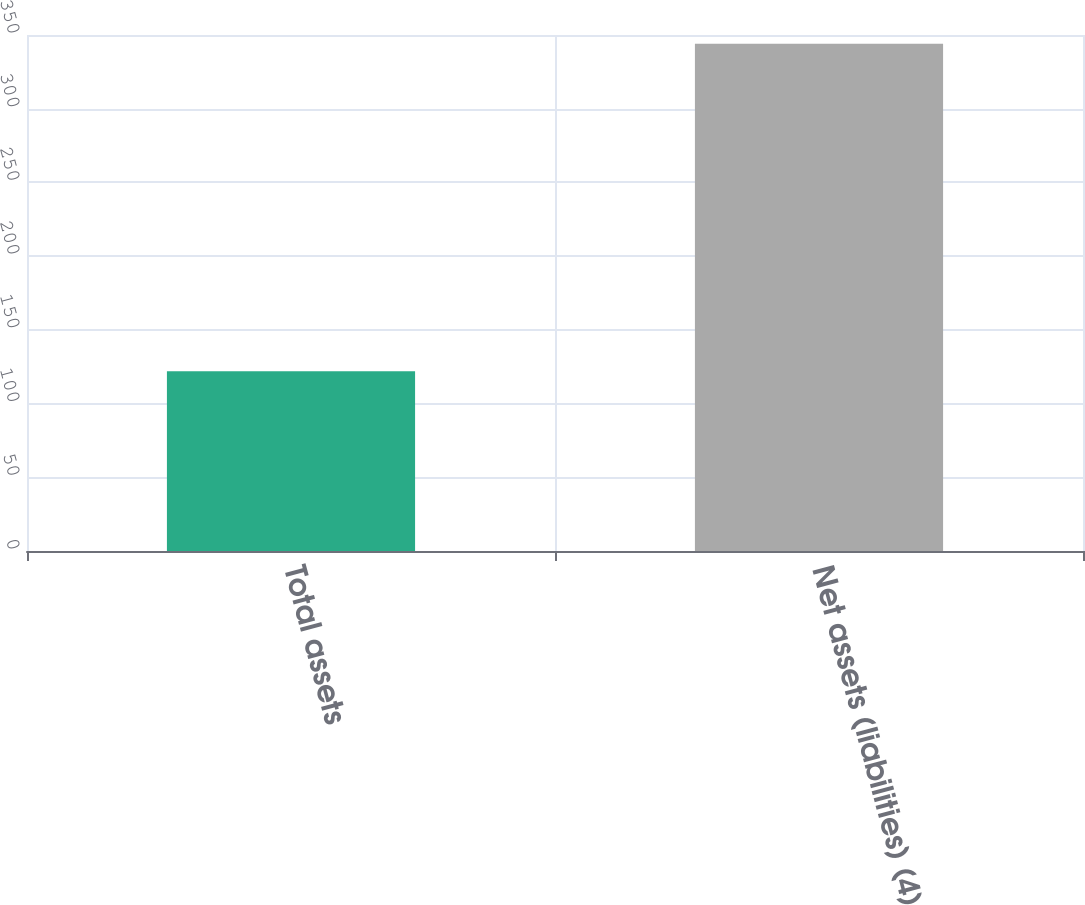Convert chart. <chart><loc_0><loc_0><loc_500><loc_500><bar_chart><fcel>Total assets<fcel>Net assets (liabilities) (4)<nl><fcel>122<fcel>344<nl></chart> 